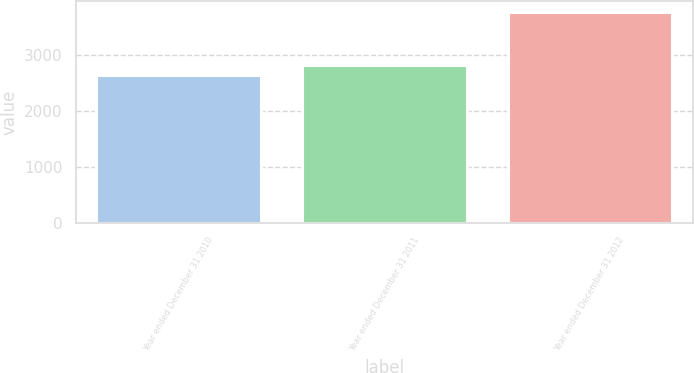<chart> <loc_0><loc_0><loc_500><loc_500><bar_chart><fcel>Year ended December 31 2010<fcel>Year ended December 31 2011<fcel>Year ended December 31 2012<nl><fcel>2648<fcel>2824<fcel>3770<nl></chart> 